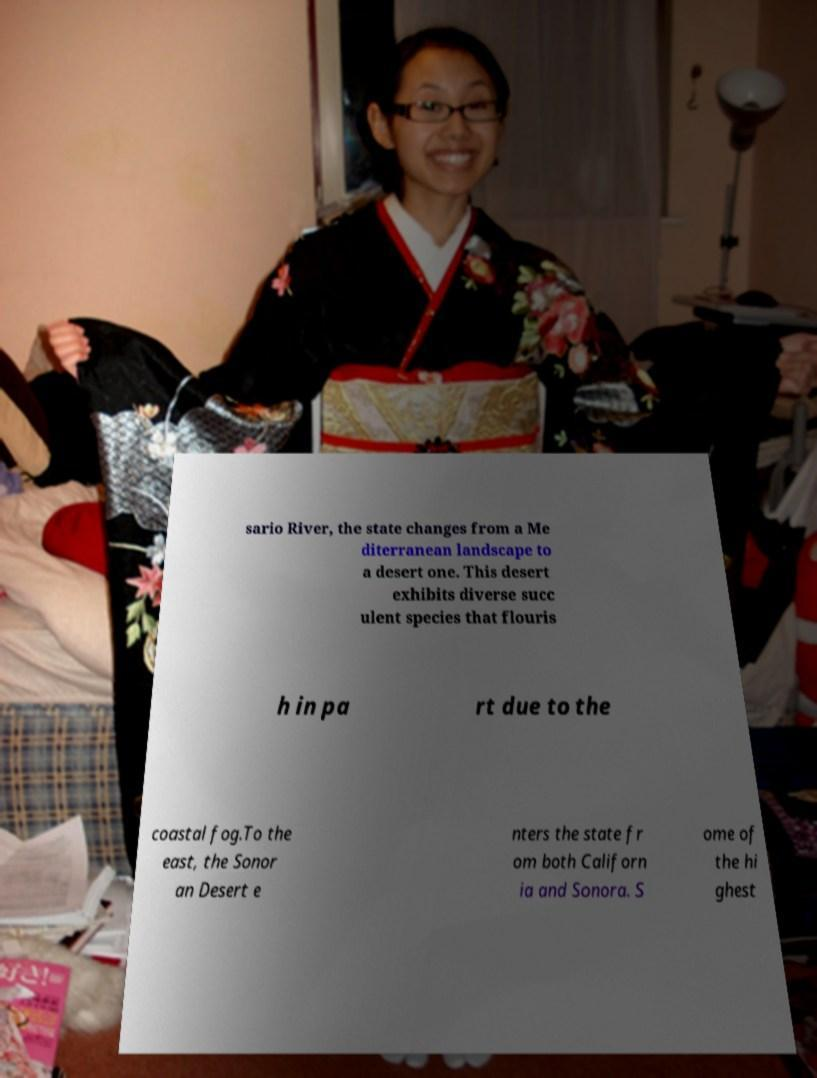Could you assist in decoding the text presented in this image and type it out clearly? sario River, the state changes from a Me diterranean landscape to a desert one. This desert exhibits diverse succ ulent species that flouris h in pa rt due to the coastal fog.To the east, the Sonor an Desert e nters the state fr om both Californ ia and Sonora. S ome of the hi ghest 